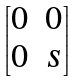<formula> <loc_0><loc_0><loc_500><loc_500>\begin{bmatrix} 0 & 0 \\ 0 & s \end{bmatrix}</formula> 